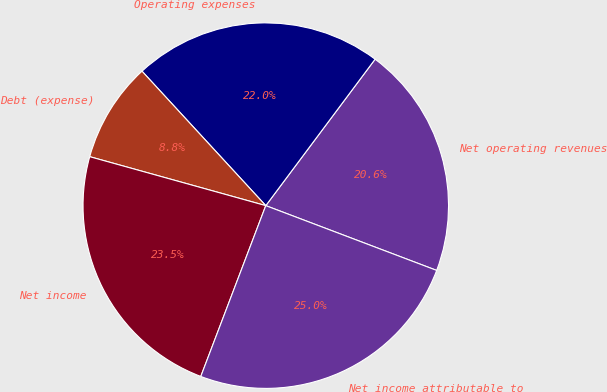<chart> <loc_0><loc_0><loc_500><loc_500><pie_chart><fcel>Net operating revenues<fcel>Operating expenses<fcel>Debt (expense)<fcel>Net income<fcel>Net income attributable to<nl><fcel>20.56%<fcel>22.05%<fcel>8.84%<fcel>23.53%<fcel>25.02%<nl></chart> 